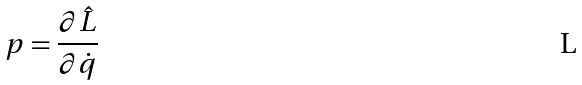Convert formula to latex. <formula><loc_0><loc_0><loc_500><loc_500>p = \frac { \partial \hat { L } } { \partial \dot { q } }</formula> 